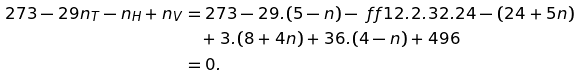Convert formula to latex. <formula><loc_0><loc_0><loc_500><loc_500>2 7 3 - 2 9 n _ { T } - n _ { H } + n _ { V } & = 2 7 3 - 2 9 . ( 5 - n ) - \ f f 1 2 . 2 . 3 2 . 2 4 - ( 2 4 + 5 n ) \\ & \quad + 3 . ( 8 + 4 n ) + 3 6 . ( 4 - n ) + 4 9 6 \\ & = 0 .</formula> 